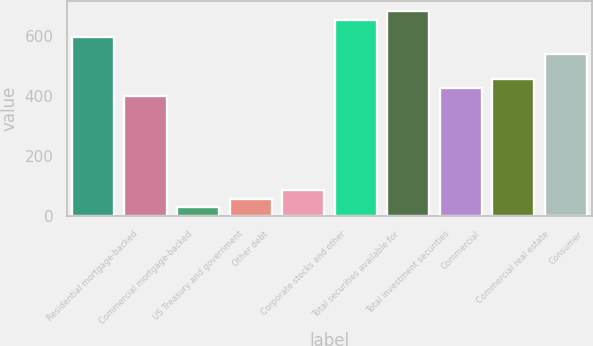Convert chart. <chart><loc_0><loc_0><loc_500><loc_500><bar_chart><fcel>Residential mortgage-backed<fcel>Commercial mortgage-backed<fcel>US Treasury and government<fcel>Other debt<fcel>Corporate stocks and other<fcel>Total securities available for<fcel>Total investment securities<fcel>Commercial<fcel>Commercial real estate<fcel>Consumer<nl><fcel>597.4<fcel>398.6<fcel>29.4<fcel>57.8<fcel>86.2<fcel>654.2<fcel>682.6<fcel>427<fcel>455.4<fcel>540.6<nl></chart> 